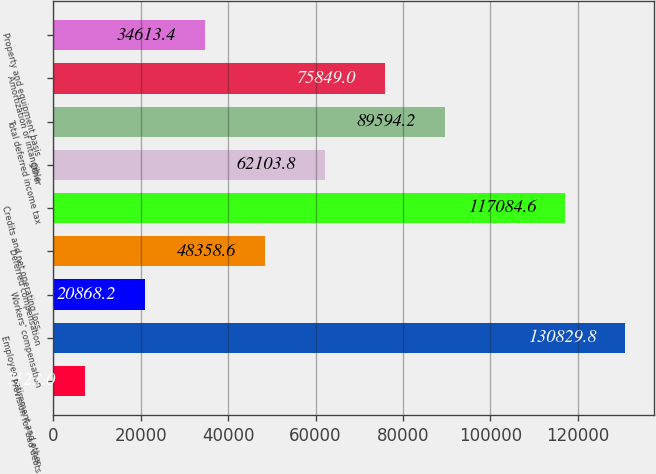Convert chart to OTSL. <chart><loc_0><loc_0><loc_500><loc_500><bar_chart><fcel>Provision for bad debts<fcel>Employee retirement and other<fcel>Workers' compensation<fcel>Deferred compensation<fcel>Credits and net operating loss<fcel>Other<fcel>Total deferred income tax<fcel>Amortization of intangible<fcel>Property and equipment basis<nl><fcel>7123<fcel>130830<fcel>20868.2<fcel>48358.6<fcel>117085<fcel>62103.8<fcel>89594.2<fcel>75849<fcel>34613.4<nl></chart> 